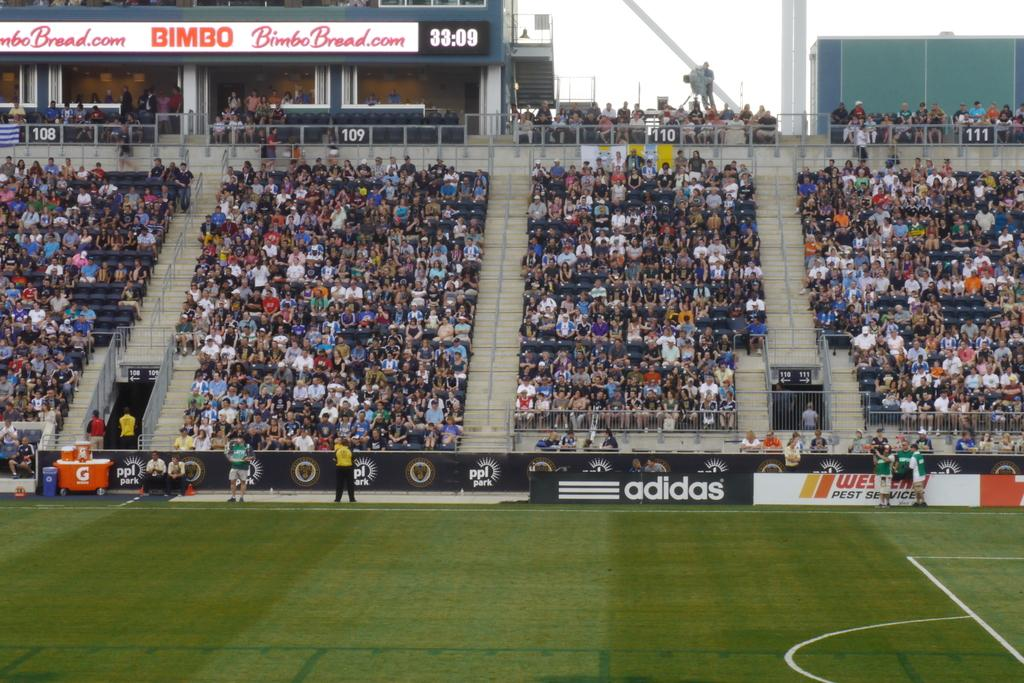Provide a one-sentence caption for the provided image. A crowd watches a soccer match amid advertisements for Bimbo bread and adidas. 